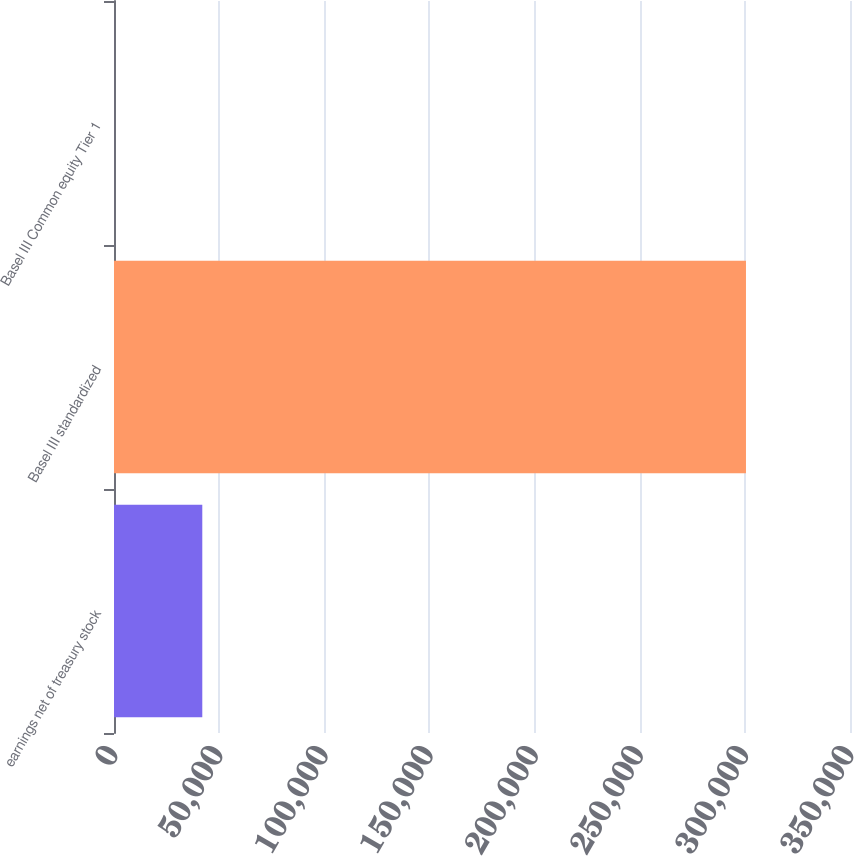Convert chart to OTSL. <chart><loc_0><loc_0><loc_500><loc_500><bar_chart><fcel>earnings net of treasury stock<fcel>Basel III standardized<fcel>Basel III Common equity Tier 1<nl><fcel>41987<fcel>300533<fcel>10.6<nl></chart> 